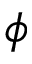<formula> <loc_0><loc_0><loc_500><loc_500>\phi</formula> 